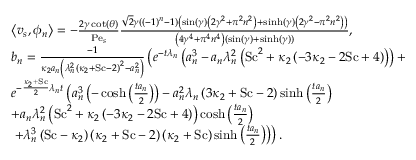Convert formula to latex. <formula><loc_0><loc_0><loc_500><loc_500>\begin{array} { r l } & { \left \langle v _ { s } , \phi _ { n } \right \rangle = - \frac { 2 \gamma \cot ( \theta ) } { P e _ { s } } \frac { \sqrt { 2 } \gamma \left ( ( - 1 ) ^ { n } - 1 \right ) \left ( \sin ( \gamma ) \left ( 2 \gamma ^ { 2 } + \pi ^ { 2 } n ^ { 2 } \right ) + \sinh ( \gamma ) \left ( 2 \gamma ^ { 2 } - \pi ^ { 2 } n ^ { 2 } \right ) \right ) } { \left ( 4 \gamma ^ { 4 } + \pi ^ { 4 } n ^ { 4 } \right ) ( \sin ( \gamma ) + \sinh ( \gamma ) ) } , } \\ & { b _ { n } = \frac { - 1 } { \kappa _ { 2 } a _ { n } \left ( \lambda _ { n } ^ { 2 } \left ( \kappa _ { 2 } + S c - 2 \right ) ^ { 2 } - a _ { n } ^ { 2 } \right ) } \left ( e ^ { - t \lambda _ { n } } \left ( a _ { n } ^ { 3 } - a _ { n } \lambda _ { n } ^ { 2 } \left ( S c ^ { 2 } + \kappa _ { 2 } \left ( - 3 \kappa _ { 2 } - 2 S c + 4 \right ) \right ) \right ) + } \\ & { e ^ { - \frac { \kappa _ { 2 } + S c } { 2 } \lambda _ { n } t } \left ( a _ { n } ^ { 3 } \left ( - \cosh \left ( \frac { t a _ { n } } { 2 } \right ) \right ) - a _ { n } ^ { 2 } \lambda _ { n } \left ( 3 \kappa _ { 2 } + S c - 2 \right ) \sinh \left ( \frac { t a _ { n } } { 2 } \right ) } \\ & { + a _ { n } \lambda _ { n } ^ { 2 } \left ( S c ^ { 2 } + \kappa _ { 2 } \left ( - 3 \kappa _ { 2 } - 2 S c + 4 \right ) \right ) \cosh \left ( \frac { t a _ { n } } { 2 } \right ) } \\ & { + \lambda _ { n } ^ { 3 } \left ( S c - \kappa _ { 2 } \right ) \left ( \kappa _ { 2 } + S c - 2 \right ) \left ( \kappa _ { 2 } + S c \right ) \sinh \left ( \frac { t a _ { n } } { 2 } \right ) \right ) \right ) . } \end{array}</formula> 